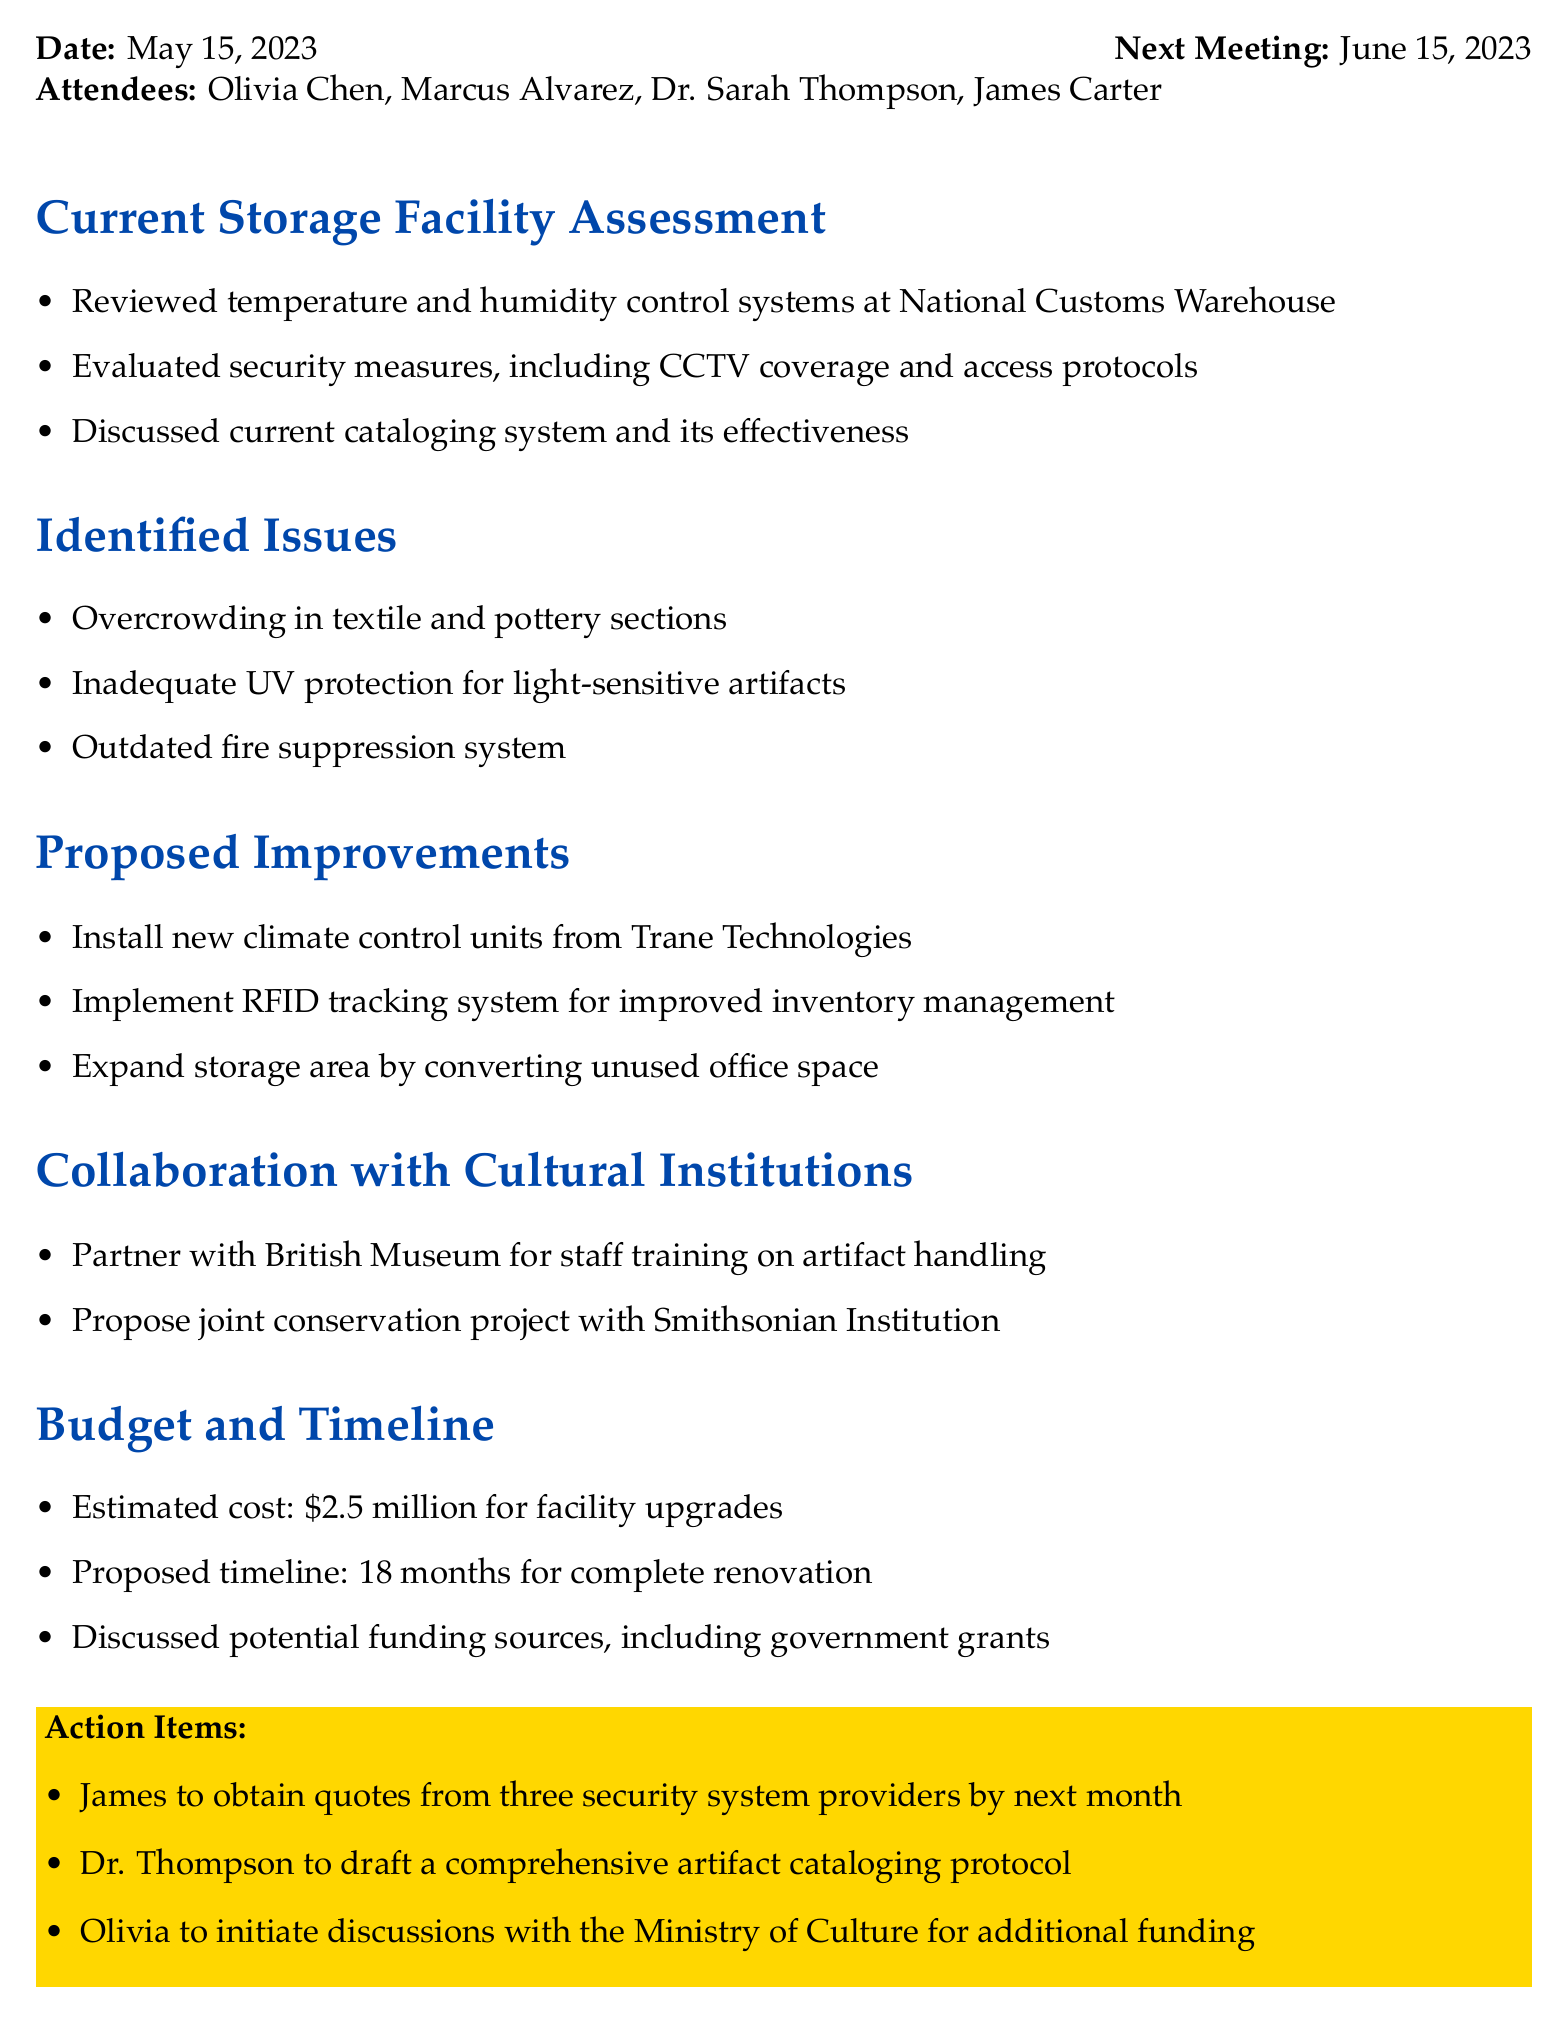What is the date of the meeting? The date of the meeting is specified in the document.
Answer: May 15, 2023 Who evaluated the security measures? The attendees included several individuals, one of whom is responsible for evaluating security.
Answer: Marcus Alvarez What is the estimated cost for facility upgrades? The estimated cost for improvements is given in the budget section of the document.
Answer: 2.5 million What kind of tracking system is proposed for inventory management? The proposed tracking system is mentioned in the proposed improvements section.
Answer: RFID tracking system What is one identified issue related to artifact storage? The document lists several issues, one of which can be highlighted.
Answer: Inadequate UV protection How long is the proposed timeline for complete renovation? The proposed timeline is stated in the budget and timeline section.
Answer: 18 months What action item is assigned to James? The action items specify tasks assigned to attendees, including one for James.
Answer: Obtain quotes from three security system providers What cultural institution is proposed for partnership regarding artifact handling? The document mentions a partnership proposal in the collaboration section.
Answer: British Museum 